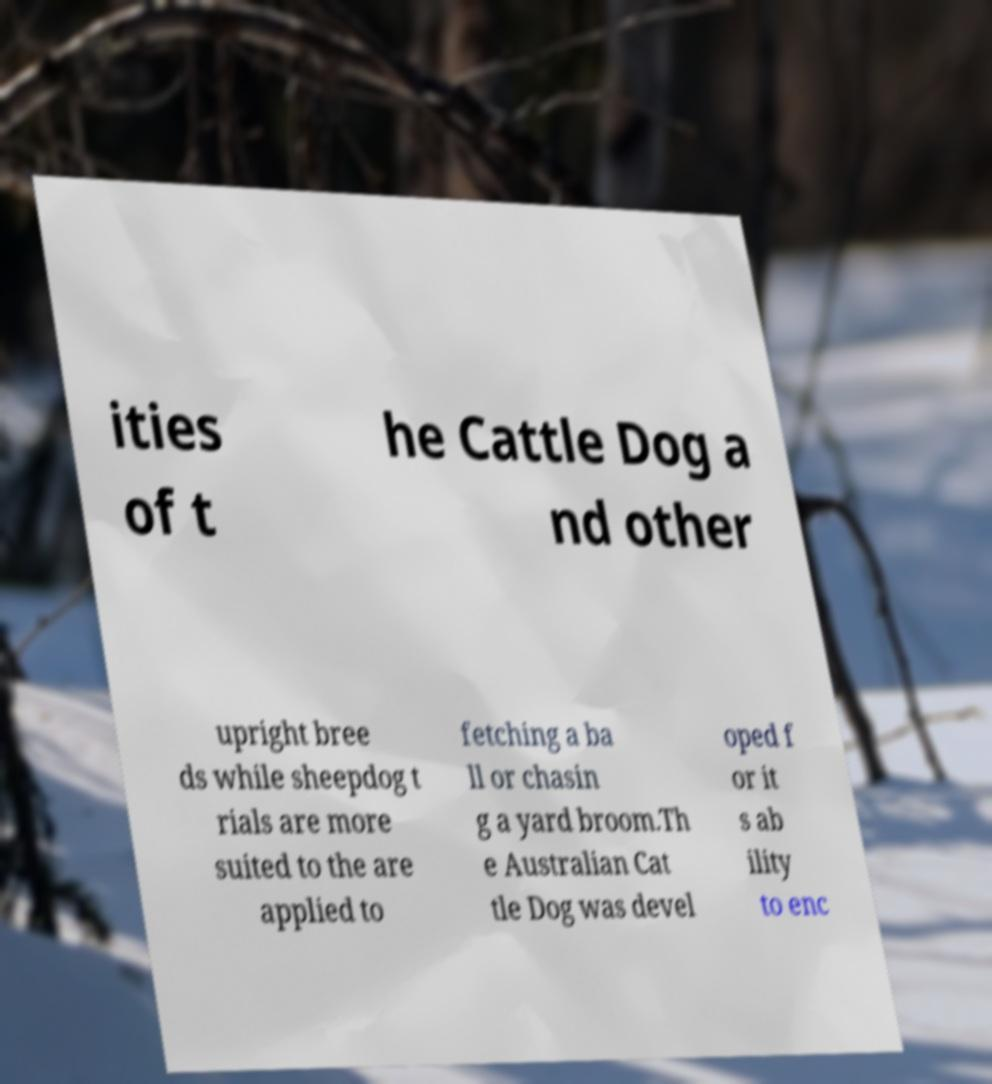Please read and relay the text visible in this image. What does it say? ities of t he Cattle Dog a nd other upright bree ds while sheepdog t rials are more suited to the are applied to fetching a ba ll or chasin g a yard broom.Th e Australian Cat tle Dog was devel oped f or it s ab ility to enc 